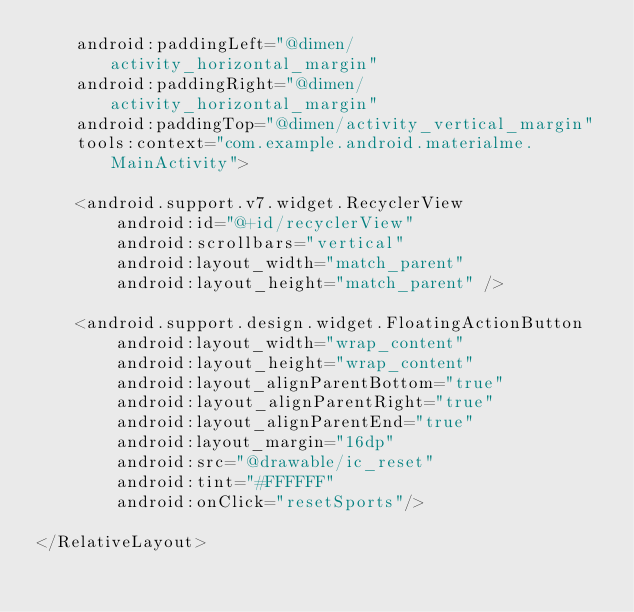<code> <loc_0><loc_0><loc_500><loc_500><_XML_>    android:paddingLeft="@dimen/activity_horizontal_margin"
    android:paddingRight="@dimen/activity_horizontal_margin"
    android:paddingTop="@dimen/activity_vertical_margin"
    tools:context="com.example.android.materialme.MainActivity">

    <android.support.v7.widget.RecyclerView
        android:id="@+id/recyclerView"
        android:scrollbars="vertical"
        android:layout_width="match_parent"
        android:layout_height="match_parent" />

    <android.support.design.widget.FloatingActionButton
        android:layout_width="wrap_content"
        android:layout_height="wrap_content"
        android:layout_alignParentBottom="true"
        android:layout_alignParentRight="true"
        android:layout_alignParentEnd="true"
        android:layout_margin="16dp"
        android:src="@drawable/ic_reset"
        android:tint="#FFFFFF"
        android:onClick="resetSports"/>

</RelativeLayout>
</code> 